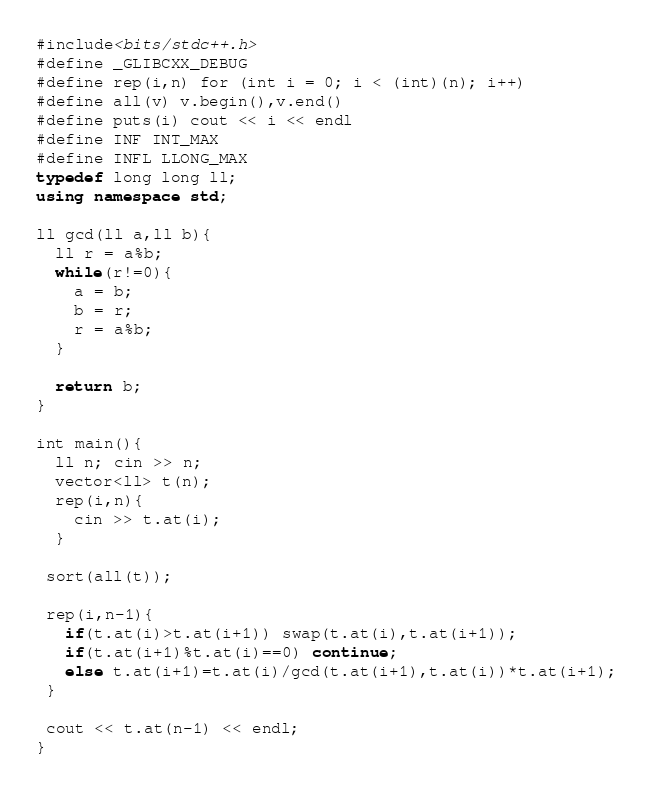<code> <loc_0><loc_0><loc_500><loc_500><_C++_>#include<bits/stdc++.h>
#define _GLIBCXX_DEBUG
#define rep(i,n) for (int i = 0; i < (int)(n); i++)
#define all(v) v.begin(),v.end()
#define puts(i) cout << i << endl
#define INF INT_MAX
#define INFL LLONG_MAX
typedef long long ll;
using namespace std;

ll gcd(ll a,ll b){
  ll r = a%b;
  while(r!=0){
    a = b;
    b = r;
    r = a%b;
  }

  return b;
}

int main(){
  ll n; cin >> n;
  vector<ll> t(n);
  rep(i,n){
    cin >> t.at(i);
  }

 sort(all(t));

 rep(i,n-1){
   if(t.at(i)>t.at(i+1)) swap(t.at(i),t.at(i+1));
   if(t.at(i+1)%t.at(i)==0) continue;
   else t.at(i+1)=t.at(i)/gcd(t.at(i+1),t.at(i))*t.at(i+1);
 }

 cout << t.at(n-1) << endl;
}
</code> 